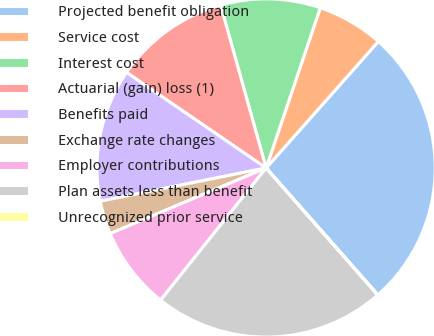<chart> <loc_0><loc_0><loc_500><loc_500><pie_chart><fcel>Projected benefit obligation<fcel>Service cost<fcel>Interest cost<fcel>Actuarial (gain) loss (1)<fcel>Benefits paid<fcel>Exchange rate changes<fcel>Employer contributions<fcel>Plan assets less than benefit<fcel>Unrecognized prior service<nl><fcel>26.95%<fcel>6.36%<fcel>9.53%<fcel>11.11%<fcel>12.7%<fcel>3.19%<fcel>7.94%<fcel>22.2%<fcel>0.02%<nl></chart> 